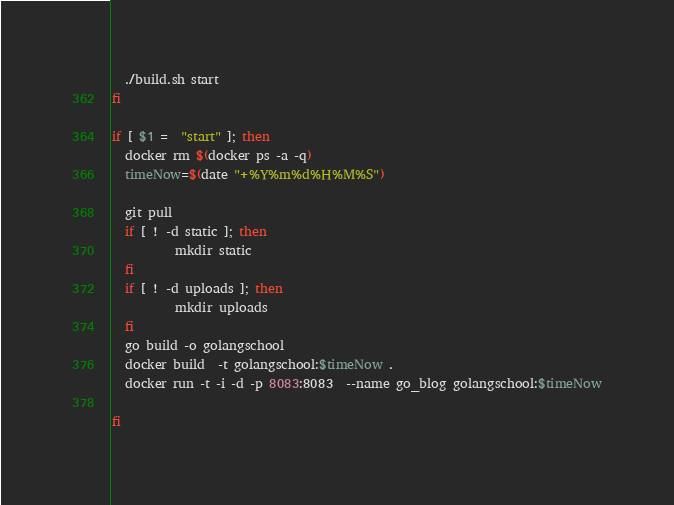Convert code to text. <code><loc_0><loc_0><loc_500><loc_500><_Bash_>  ./build.sh start
fi

if [ $1 =  "start" ]; then
  docker rm $(docker ps -a -q)
  timeNow=$(date "+%Y%m%d%H%M%S")

  git pull
  if [ ! -d static ]; then
          mkdir static
  fi
  if [ ! -d uploads ]; then
          mkdir uploads
  fi
  go build -o golangschool
  docker build  -t golangschool:$timeNow .
  docker run -t -i -d -p 8083:8083  --name go_blog golangschool:$timeNow

fi</code> 